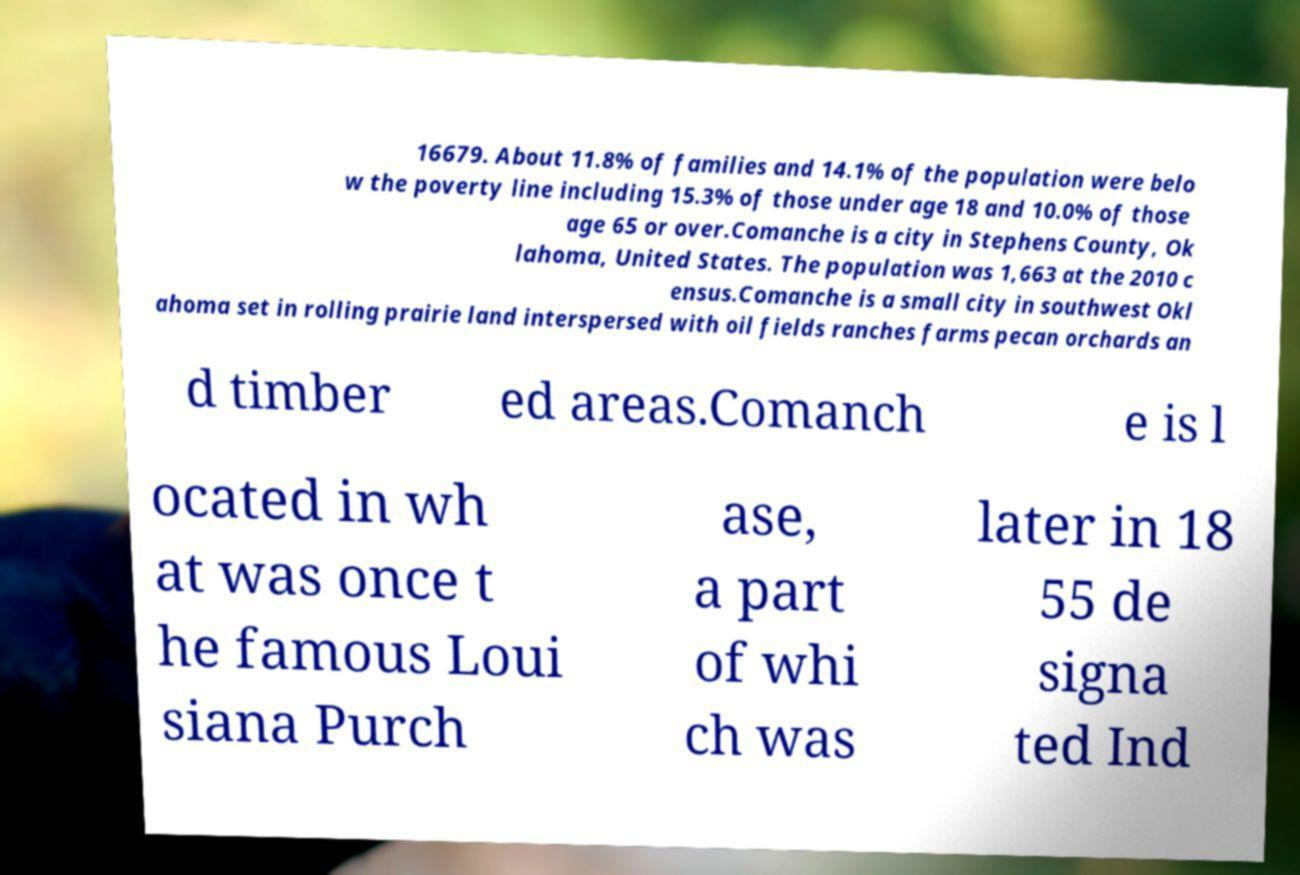For documentation purposes, I need the text within this image transcribed. Could you provide that? 16679. About 11.8% of families and 14.1% of the population were belo w the poverty line including 15.3% of those under age 18 and 10.0% of those age 65 or over.Comanche is a city in Stephens County, Ok lahoma, United States. The population was 1,663 at the 2010 c ensus.Comanche is a small city in southwest Okl ahoma set in rolling prairie land interspersed with oil fields ranches farms pecan orchards an d timber ed areas.Comanch e is l ocated in wh at was once t he famous Loui siana Purch ase, a part of whi ch was later in 18 55 de signa ted Ind 